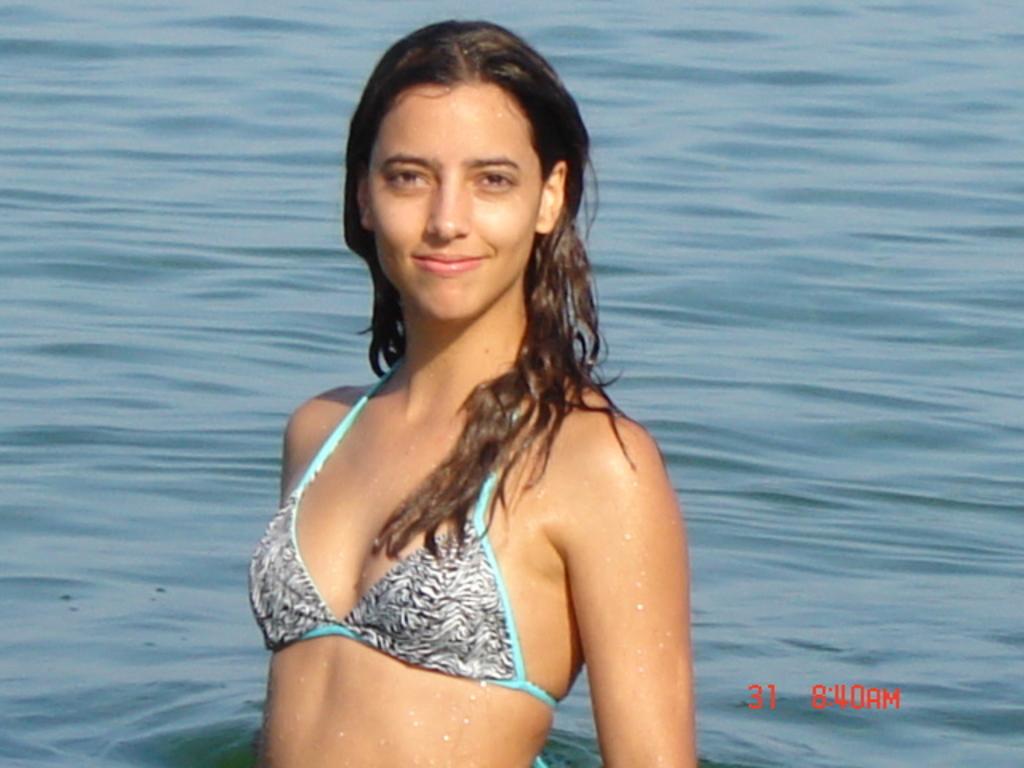Can you describe this image briefly? In this image I see a woman who is in the water and I see that she is wearing white, black and light blue color bikini and I see the watermark over here. 